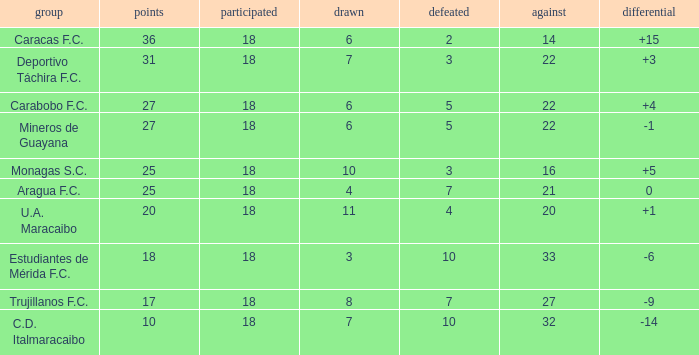What is the sum of the points of all teams that had against scores less than 14? None. 